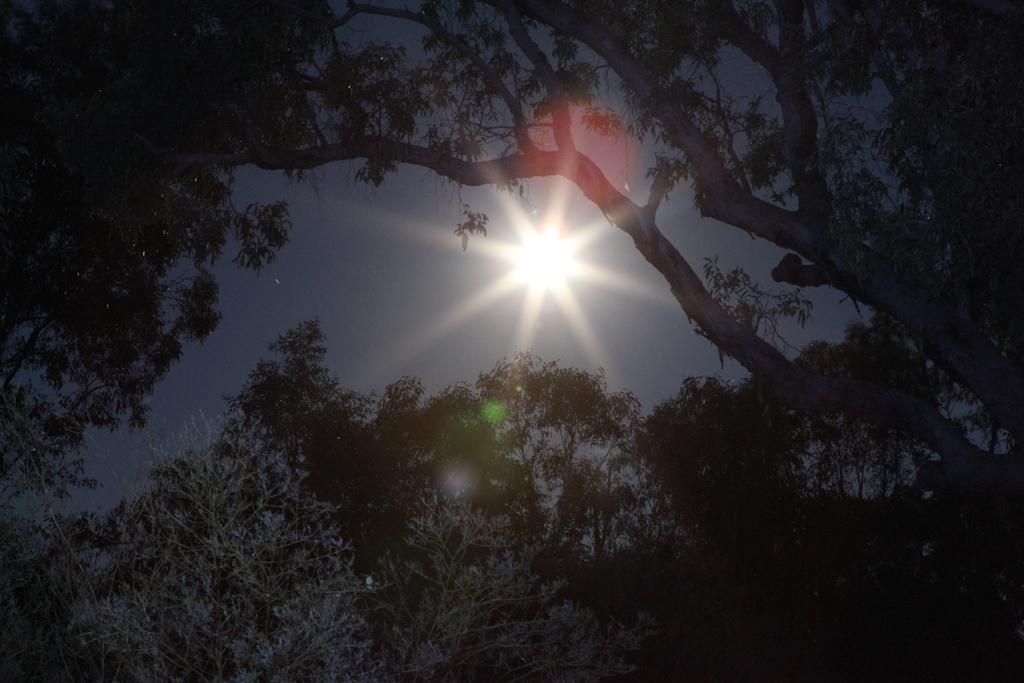Can you describe this image briefly? In this picture I can see there are trees and the sky is clear with sun. 